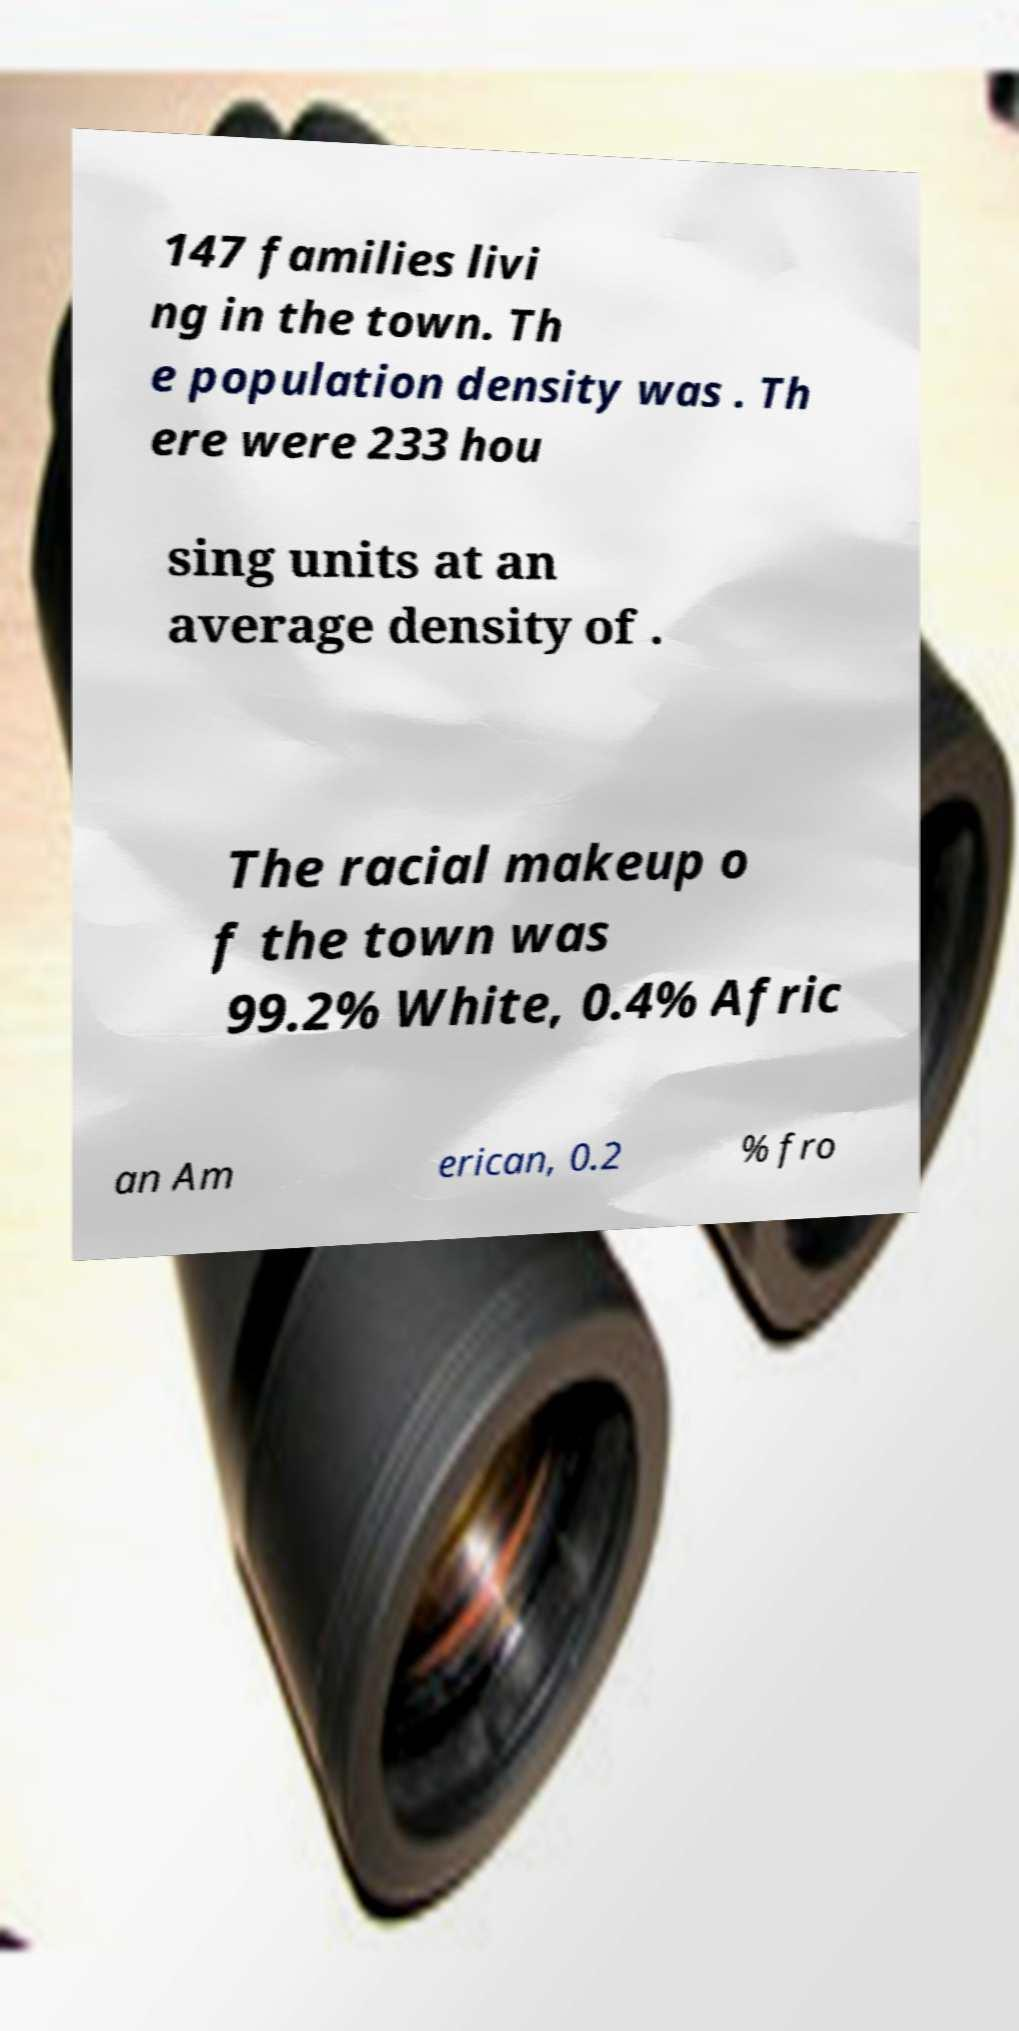Could you assist in decoding the text presented in this image and type it out clearly? 147 families livi ng in the town. Th e population density was . Th ere were 233 hou sing units at an average density of . The racial makeup o f the town was 99.2% White, 0.4% Afric an Am erican, 0.2 % fro 